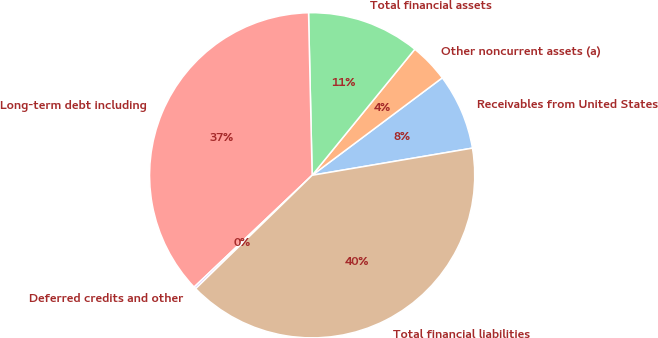Convert chart to OTSL. <chart><loc_0><loc_0><loc_500><loc_500><pie_chart><fcel>Receivables from United States<fcel>Other noncurrent assets (a)<fcel>Total financial assets<fcel>Long-term debt including<fcel>Deferred credits and other<fcel>Total financial liabilities<nl><fcel>7.56%<fcel>3.89%<fcel>11.23%<fcel>36.71%<fcel>0.22%<fcel>40.38%<nl></chart> 